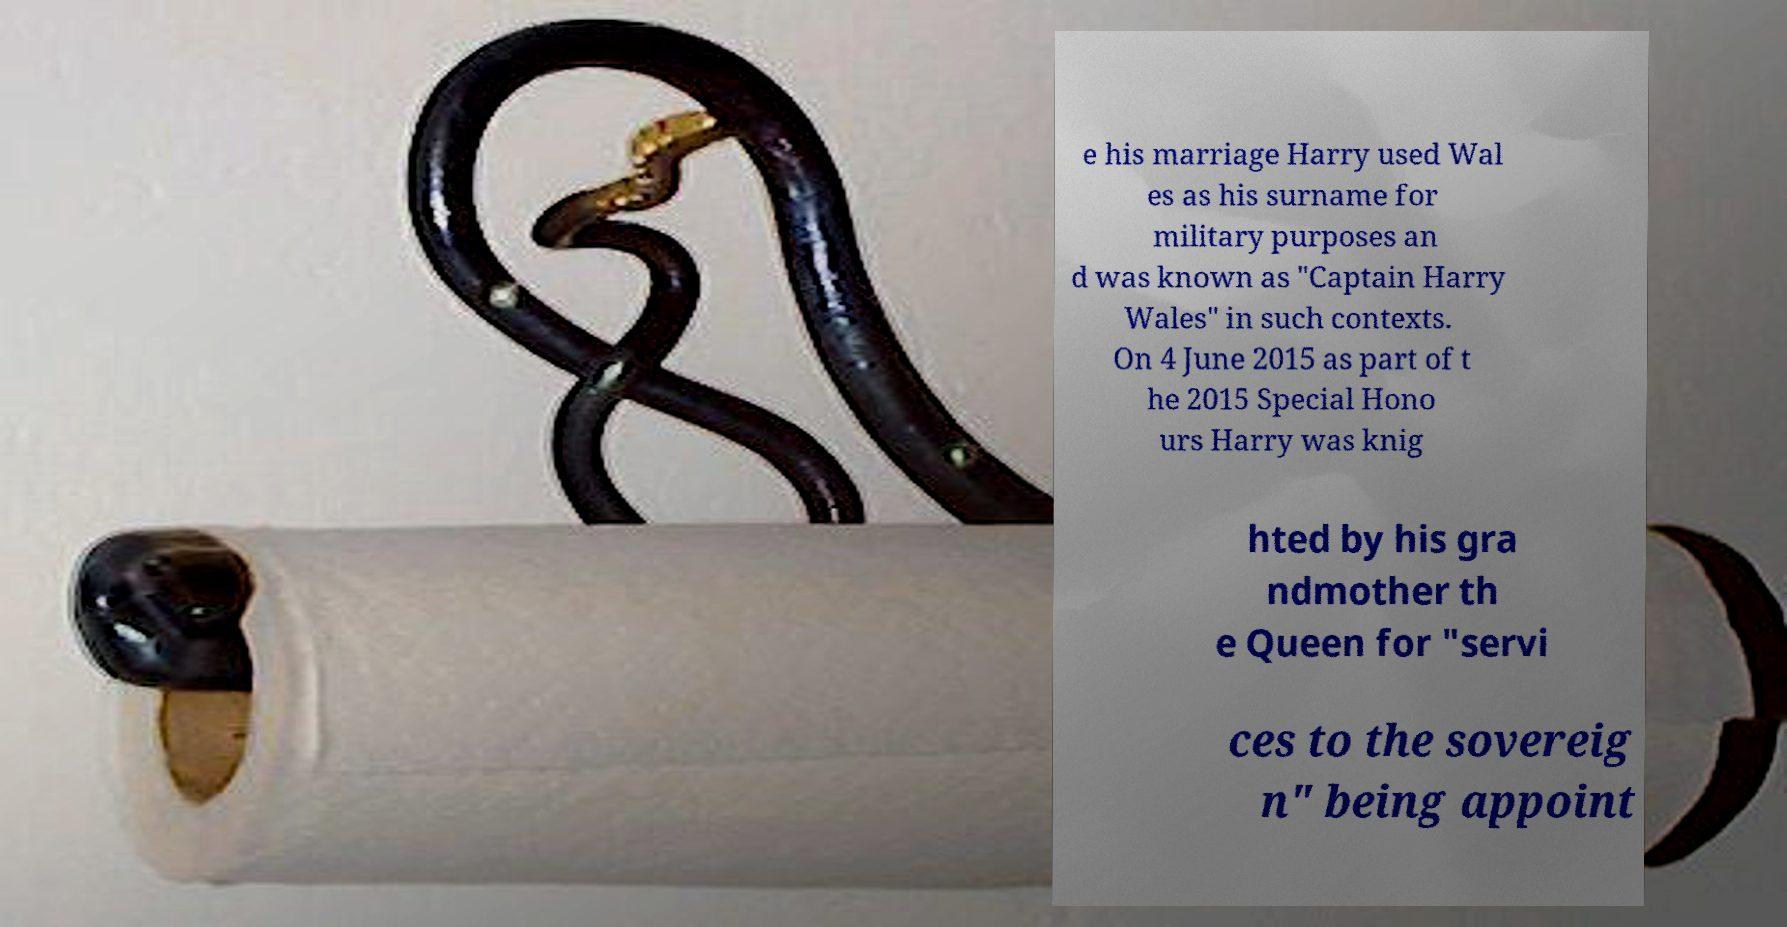Could you extract and type out the text from this image? e his marriage Harry used Wal es as his surname for military purposes an d was known as "Captain Harry Wales" in such contexts. On 4 June 2015 as part of t he 2015 Special Hono urs Harry was knig hted by his gra ndmother th e Queen for "servi ces to the sovereig n" being appoint 